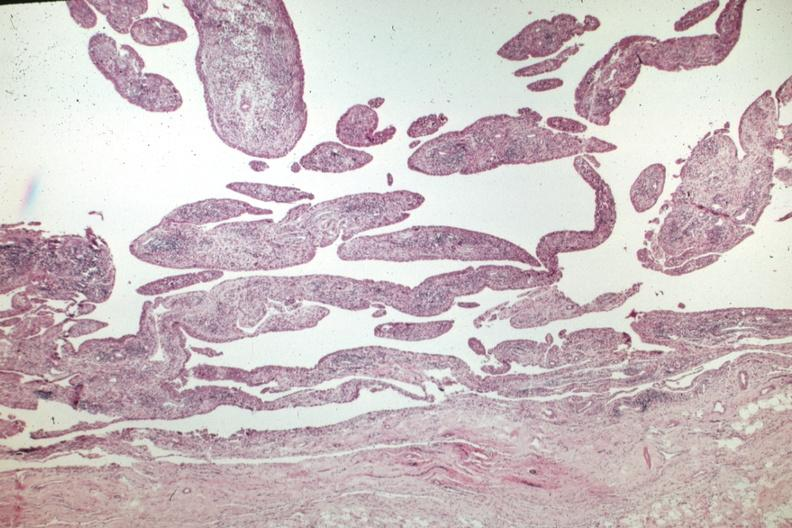what does this image show?
Answer the question using a single word or phrase. Villous lesion with chronic inflammatory cells 